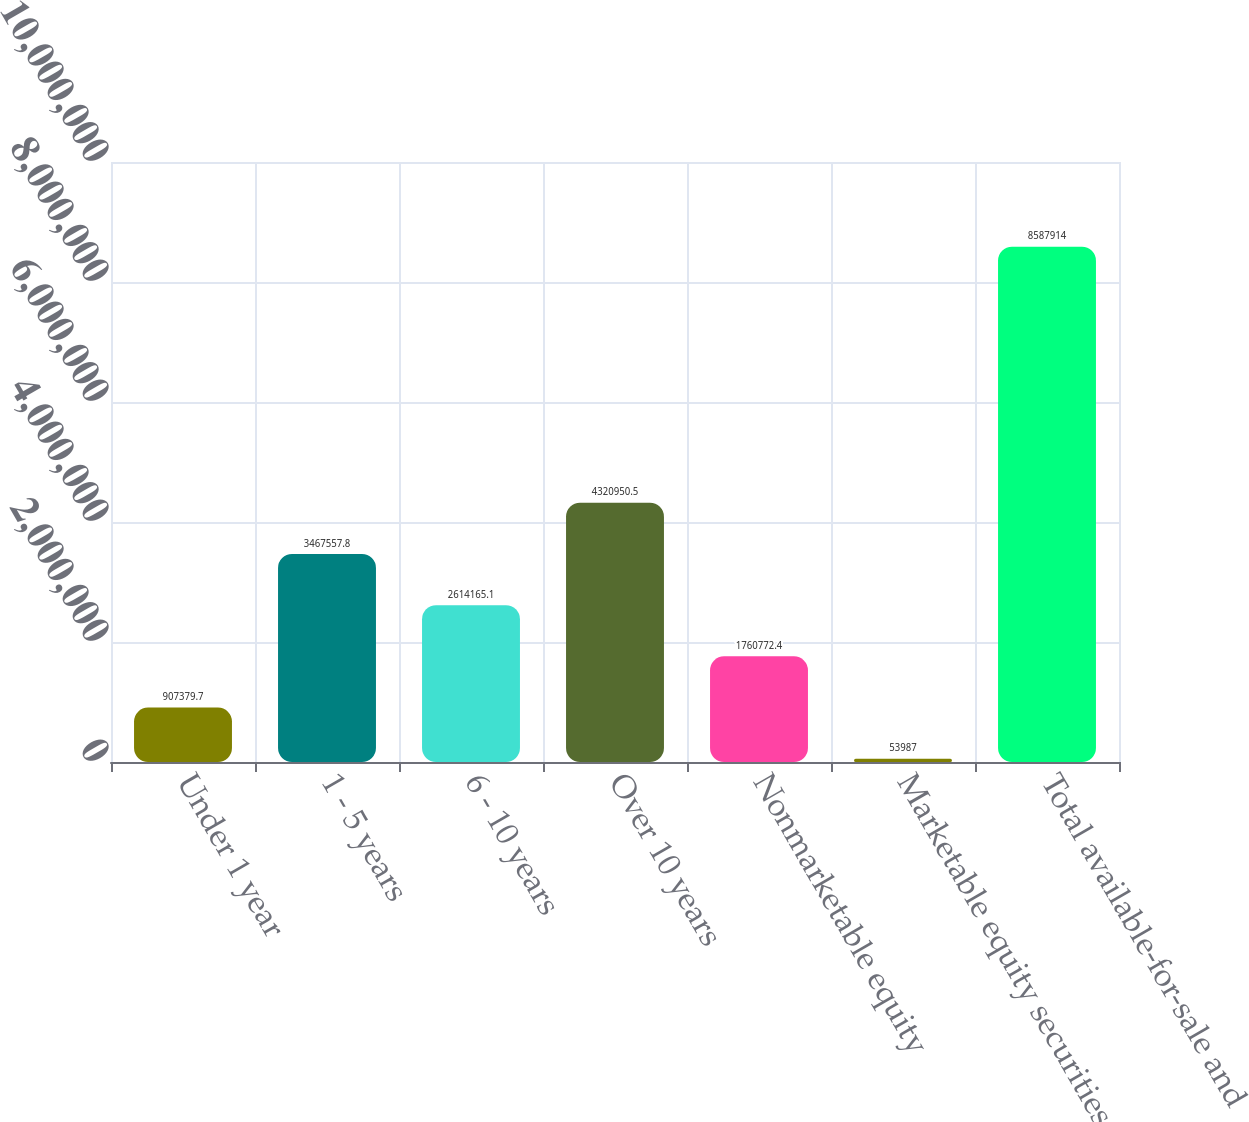Convert chart. <chart><loc_0><loc_0><loc_500><loc_500><bar_chart><fcel>Under 1 year<fcel>1 - 5 years<fcel>6 - 10 years<fcel>Over 10 years<fcel>Nonmarketable equity<fcel>Marketable equity securities<fcel>Total available-for-sale and<nl><fcel>907380<fcel>3.46756e+06<fcel>2.61417e+06<fcel>4.32095e+06<fcel>1.76077e+06<fcel>53987<fcel>8.58791e+06<nl></chart> 